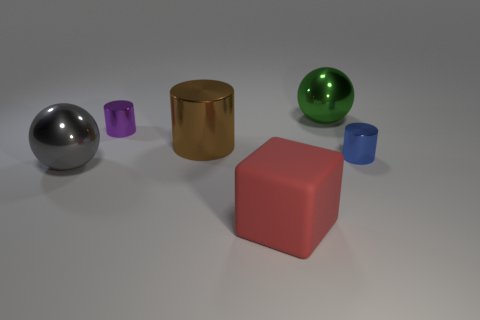Subtract all gray cubes. Subtract all gray balls. How many cubes are left? 1 Add 3 red metallic objects. How many objects exist? 9 Subtract all spheres. How many objects are left? 4 Subtract all cyan matte spheres. Subtract all big red objects. How many objects are left? 5 Add 1 small purple metal cylinders. How many small purple metal cylinders are left? 2 Add 6 large brown matte cylinders. How many large brown matte cylinders exist? 6 Subtract 0 cyan cubes. How many objects are left? 6 